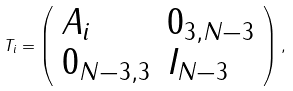Convert formula to latex. <formula><loc_0><loc_0><loc_500><loc_500>T _ { i } = \left ( \begin{array} { l l } A _ { i } & 0 _ { 3 , N - 3 } \\ 0 _ { N - 3 , 3 } & I _ { N - 3 } \end{array} \right ) ,</formula> 